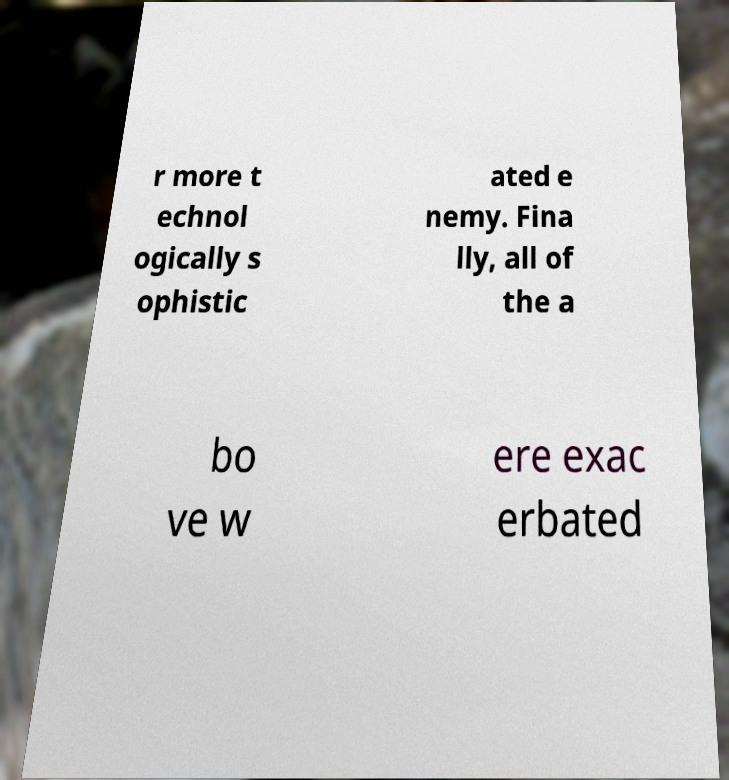Could you extract and type out the text from this image? r more t echnol ogically s ophistic ated e nemy. Fina lly, all of the a bo ve w ere exac erbated 